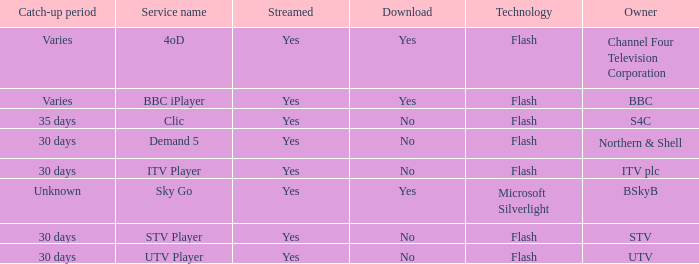What Service Name has UTV as the owner? UTV Player. 